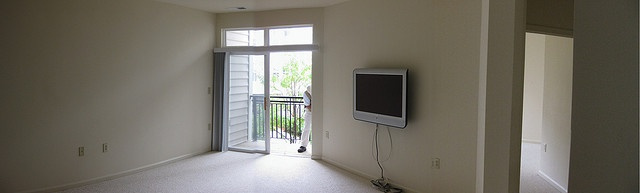Describe the objects in this image and their specific colors. I can see tv in black and gray tones and people in black, darkgray, lightgray, and gray tones in this image. 